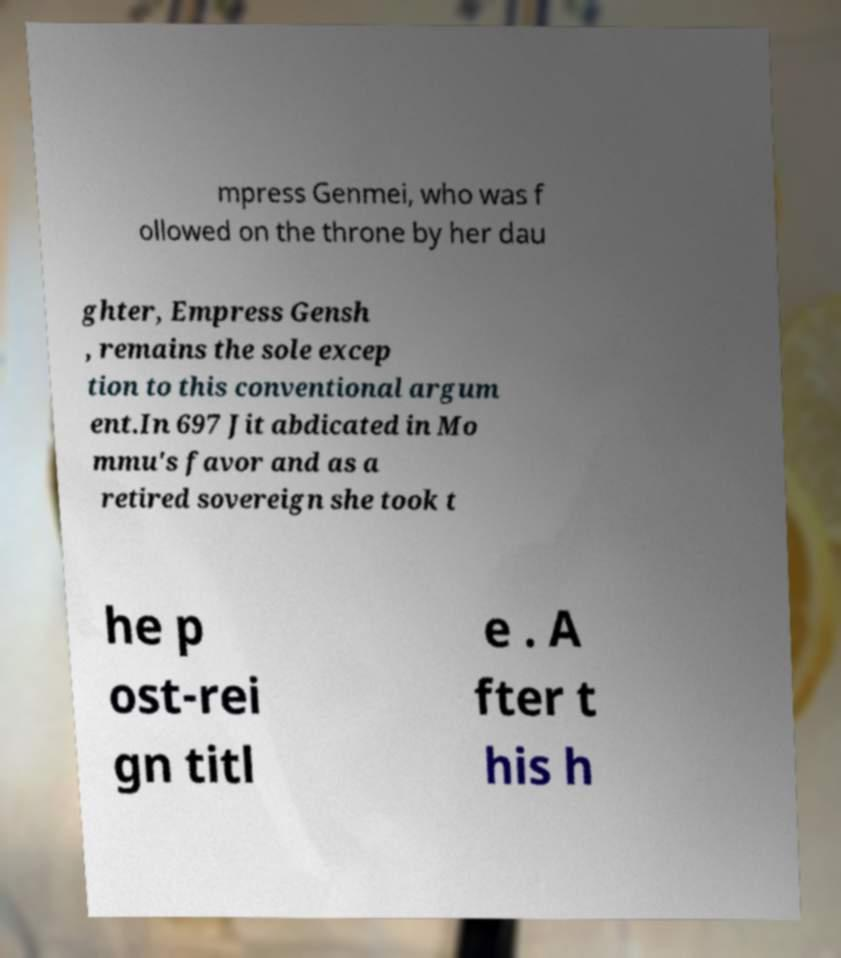For documentation purposes, I need the text within this image transcribed. Could you provide that? mpress Genmei, who was f ollowed on the throne by her dau ghter, Empress Gensh , remains the sole excep tion to this conventional argum ent.In 697 Jit abdicated in Mo mmu's favor and as a retired sovereign she took t he p ost-rei gn titl e . A fter t his h 